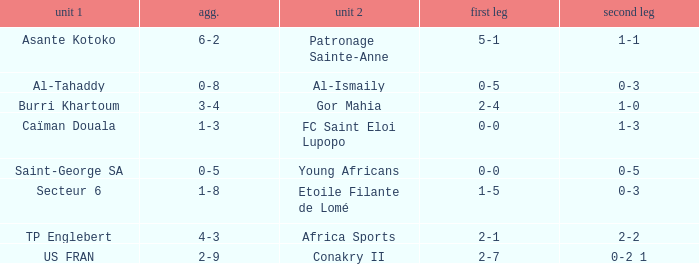Which teams had an aggregate score of 3-4? Burri Khartoum. 